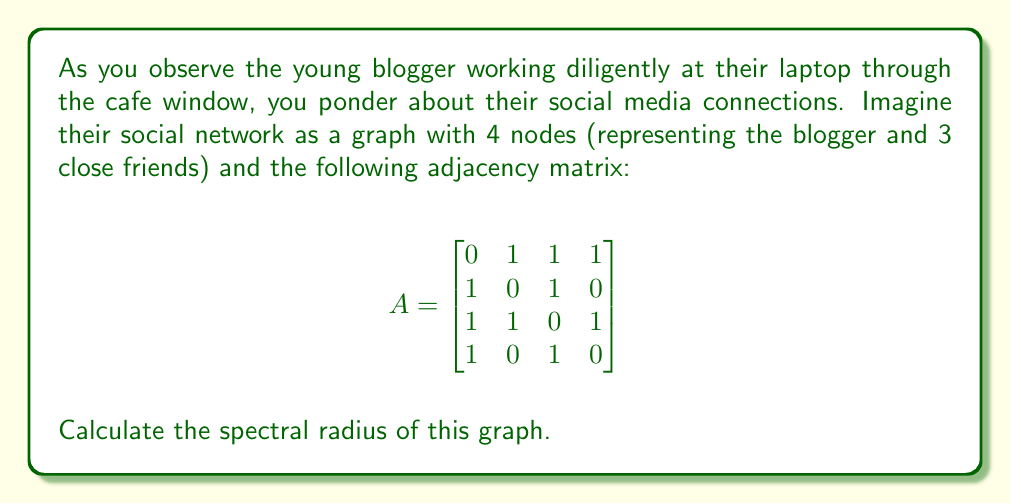Solve this math problem. To find the spectral radius of the graph, we need to follow these steps:

1) The spectral radius is the largest absolute eigenvalue of the adjacency matrix.

2) To find the eigenvalues, we need to solve the characteristic equation:
   $$det(A - \lambda I) = 0$$

3) Expanding this determinant:
   $$\begin{vmatrix}
   -\lambda & 1 & 1 & 1 \\
   1 & -\lambda & 1 & 0 \\
   1 & 1 & -\lambda & 1 \\
   1 & 0 & 1 & -\lambda
   \end{vmatrix} = 0$$

4) This expands to the characteristic polynomial:
   $$\lambda^4 - 5\lambda^2 - 4\lambda + 1 = 0$$

5) This is a 4th degree polynomial which is difficult to solve by hand. However, we can use the fact that for simple graphs, the largest eigenvalue is always real and positive.

6) Using numerical methods or a computer algebra system, we can find that the roots of this polynomial are approximately:
   $$\lambda_1 \approx 2.5616$$
   $$\lambda_2 \approx -1.6889$$
   $$\lambda_3 \approx 0.5637$$
   $$\lambda_4 \approx -0.4364$$

7) The spectral radius is the largest absolute value among these eigenvalues, which is $\lambda_1 \approx 2.5616$.
Answer: $2.5616$ (to 4 decimal places) 